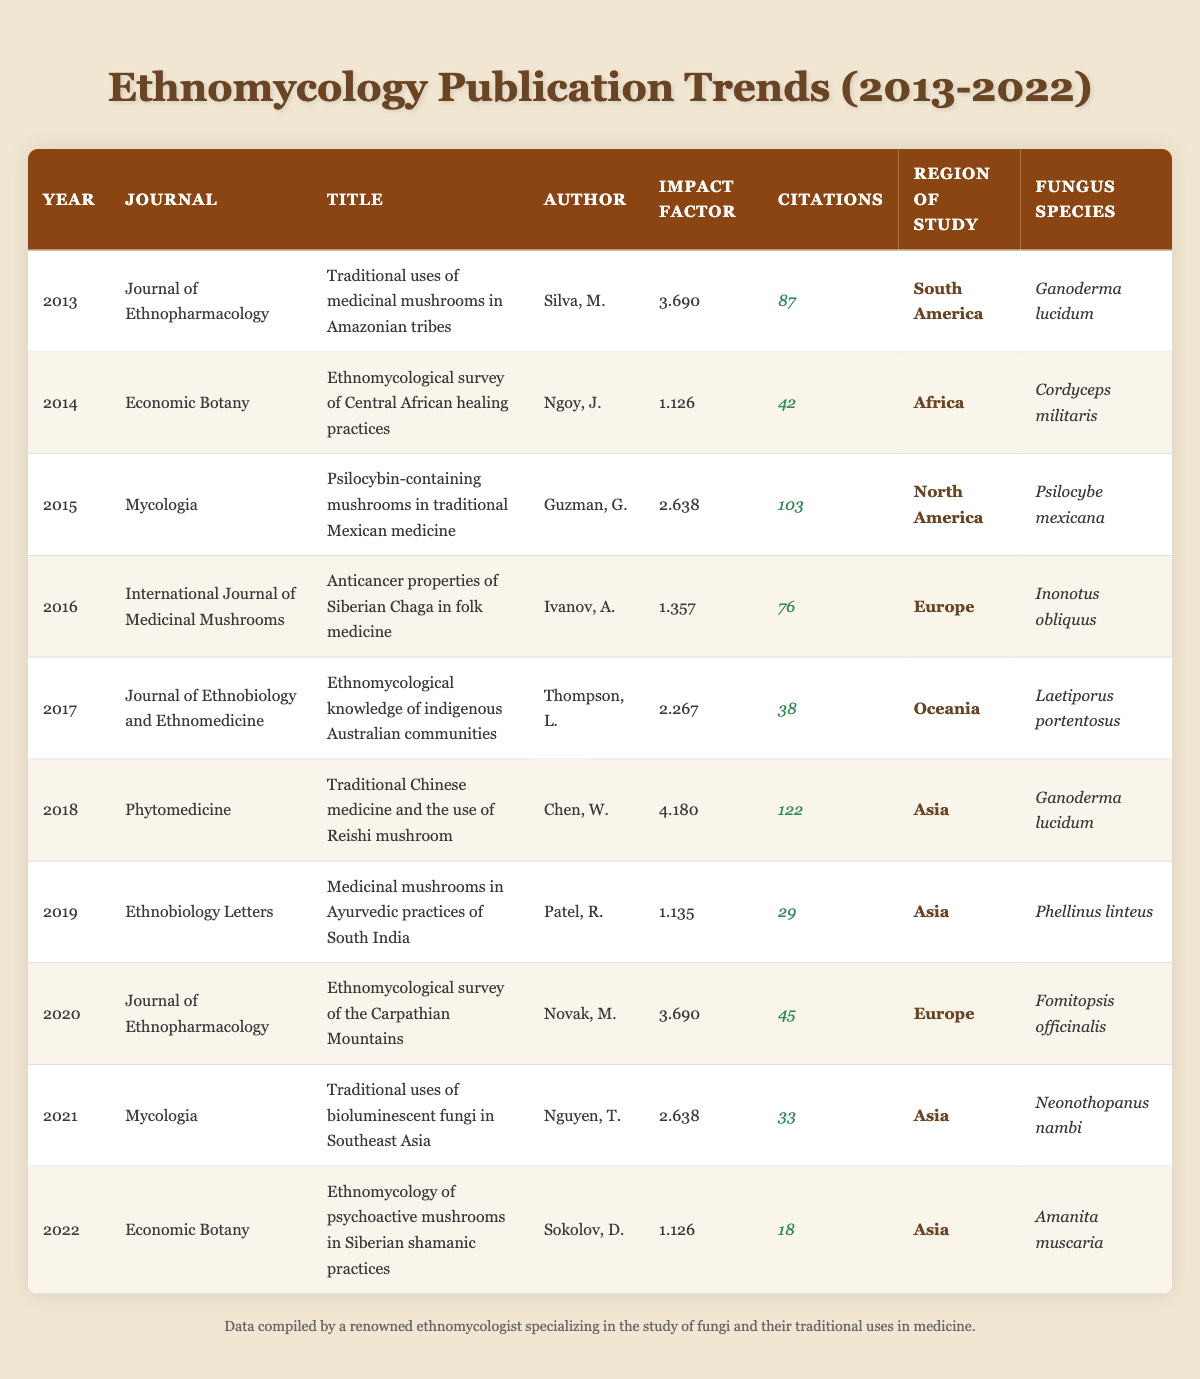What is the total number of citations for publications from the year 2015? We refer to the publication from 2015, which has 103 citations according to the table. There is only one publication from that year to consider.
Answer: 103 Which journal had the highest impact factor in 2018? The publication for 2018 is from the journal "Phytomedicine," which has an impact factor of 4.180, the highest among the listed journals for that year.
Answer: Phytomedicine How many publications studied fungi from Asia? By counting the entries in the "Region of Study" column, we find that there are five publications indicating Asia as the region: 2018, 2019, 2021, and 2022.
Answer: 5 What is the average impact factor of the publications from 2016 to 2020? The impact factors from 2016 to 2020 are: 1.357, 2.267, 4.180, and 3.690. We sum them (1.357 + 2.267 + 4.180 + 3.690) = 11.494, and since there are four publications, we divide by 4 to find the average: 11.494 / 4 = 2.8735.
Answer: 2.8735 Was there any publication in 2021 with more than 30 citations? The publication from 2021 has 33 citations according to the table, which is indeed more than 30, confirming that at least one publication meets that criterion.
Answer: Yes Which region had the lowest number of citations across its publications? By checking the citation counts for each region, Oceania has 38 citations, while Africa has 42 citations, and all other regions have higher counts. Oceania has the lowest citation count, confirming it as the region with the least citations.
Answer: Oceania In which year was the study on medicinal fungi in Amazonian tribes published? The table indicates that this specific study was published in 2013 as highlighted in the year column.
Answer: 2013 What percentage of the total citations come from studies of fungi species named Ganoderma lucidum? The publications featuring Ganoderma lucidum are from 2013 with 87 citations and from 2018 with 122 citations. Summing these citations gives us 209. The total citation count across all publications is 463 (the sum of all citations listed). The percentage is calculated as (209 / 463) * 100, which equals approximately 45.1%.
Answer: 45.1% 